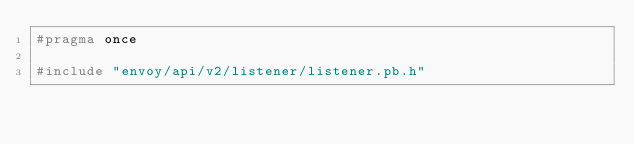Convert code to text. <code><loc_0><loc_0><loc_500><loc_500><_C_>#pragma once

#include "envoy/api/v2/listener/listener.pb.h"</code> 